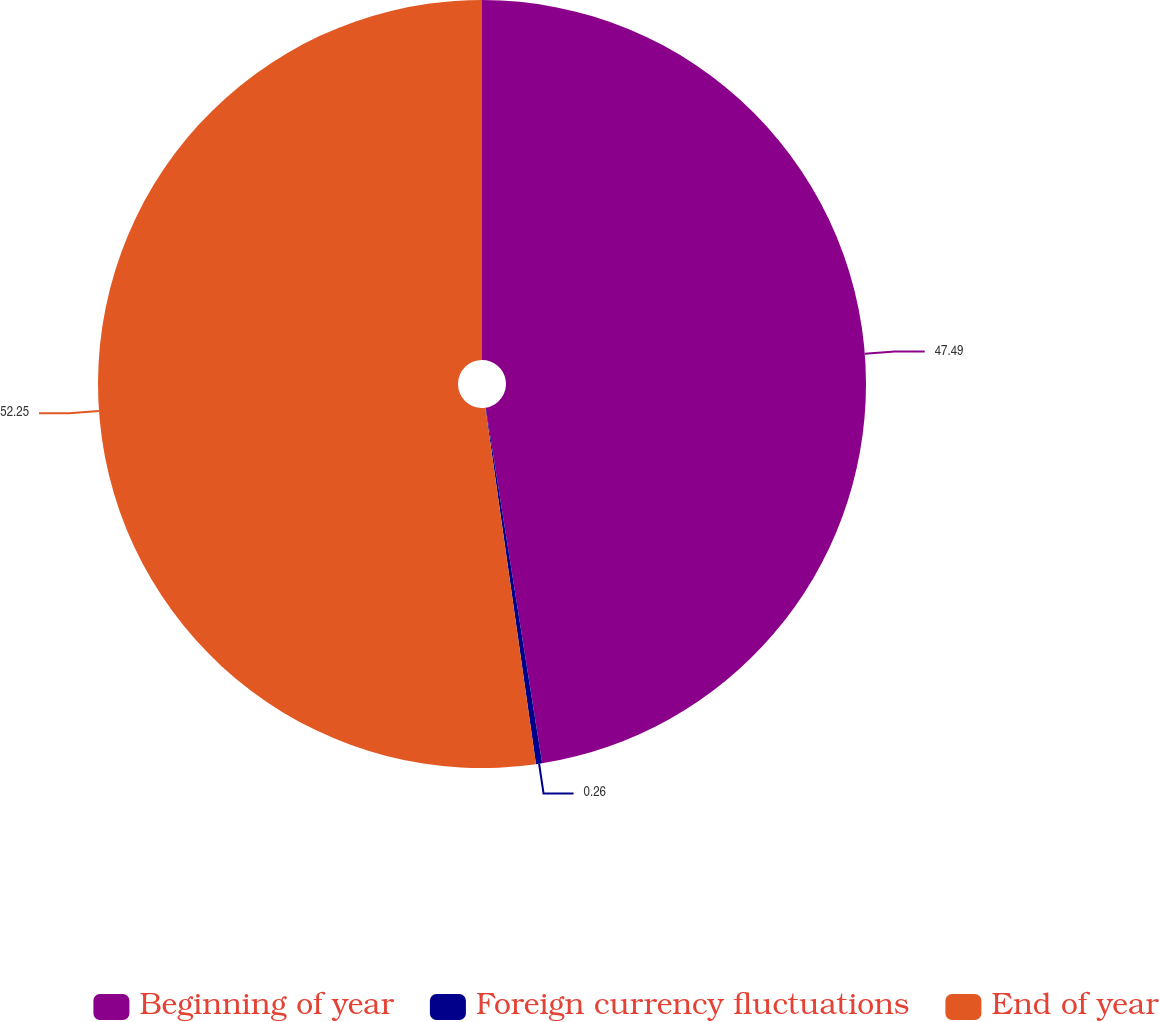<chart> <loc_0><loc_0><loc_500><loc_500><pie_chart><fcel>Beginning of year<fcel>Foreign currency fluctuations<fcel>End of year<nl><fcel>47.49%<fcel>0.26%<fcel>52.24%<nl></chart> 